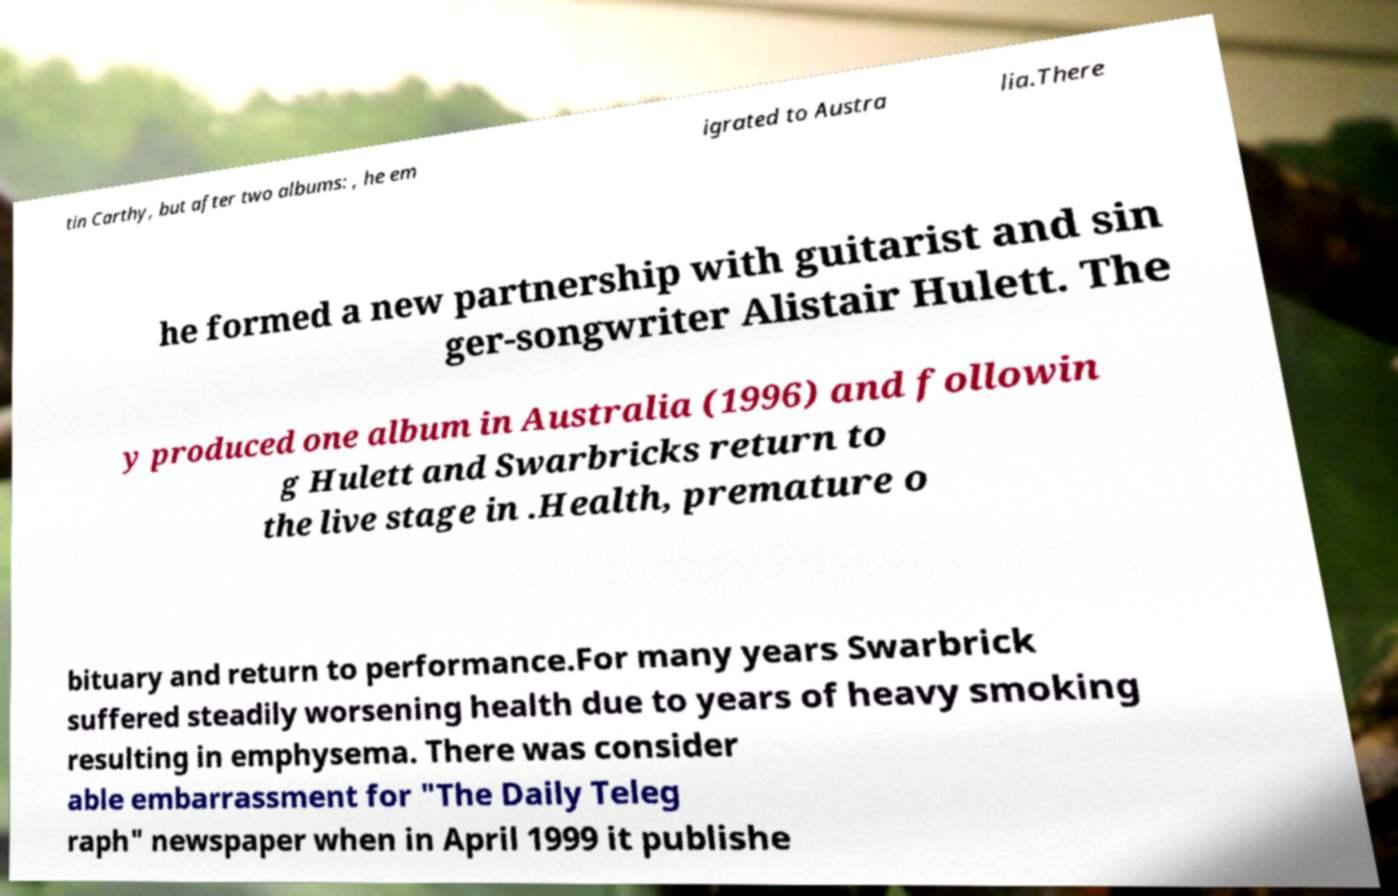Could you assist in decoding the text presented in this image and type it out clearly? tin Carthy, but after two albums: , he em igrated to Austra lia.There he formed a new partnership with guitarist and sin ger-songwriter Alistair Hulett. The y produced one album in Australia (1996) and followin g Hulett and Swarbricks return to the live stage in .Health, premature o bituary and return to performance.For many years Swarbrick suffered steadily worsening health due to years of heavy smoking resulting in emphysema. There was consider able embarrassment for "The Daily Teleg raph" newspaper when in April 1999 it publishe 